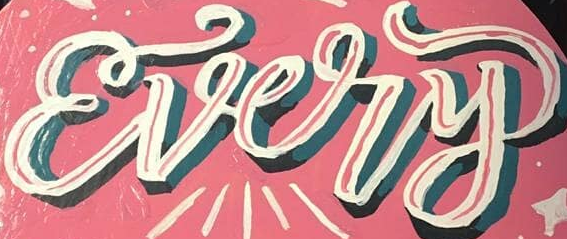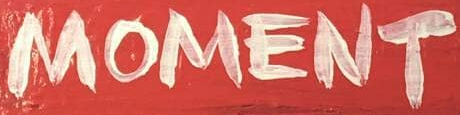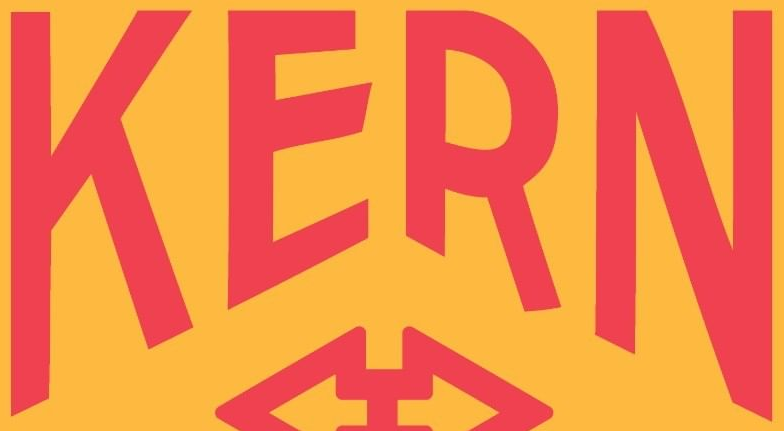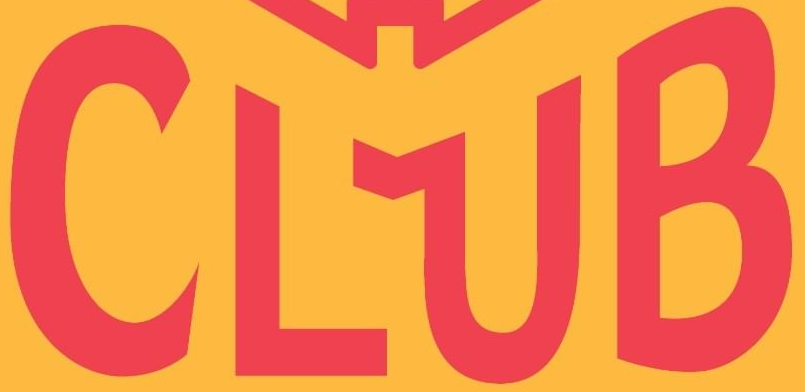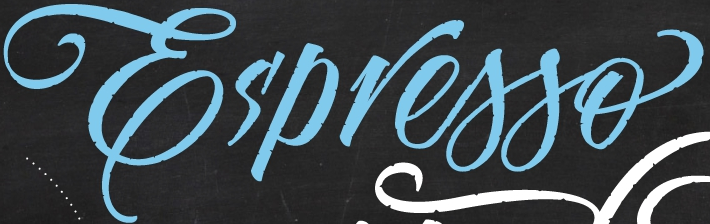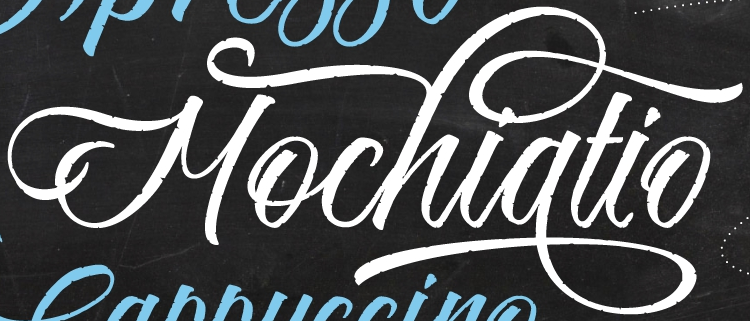What text is displayed in these images sequentially, separated by a semicolon? Every; MOMENT; KERN; CLUB; Es'presso; Mochiatio 